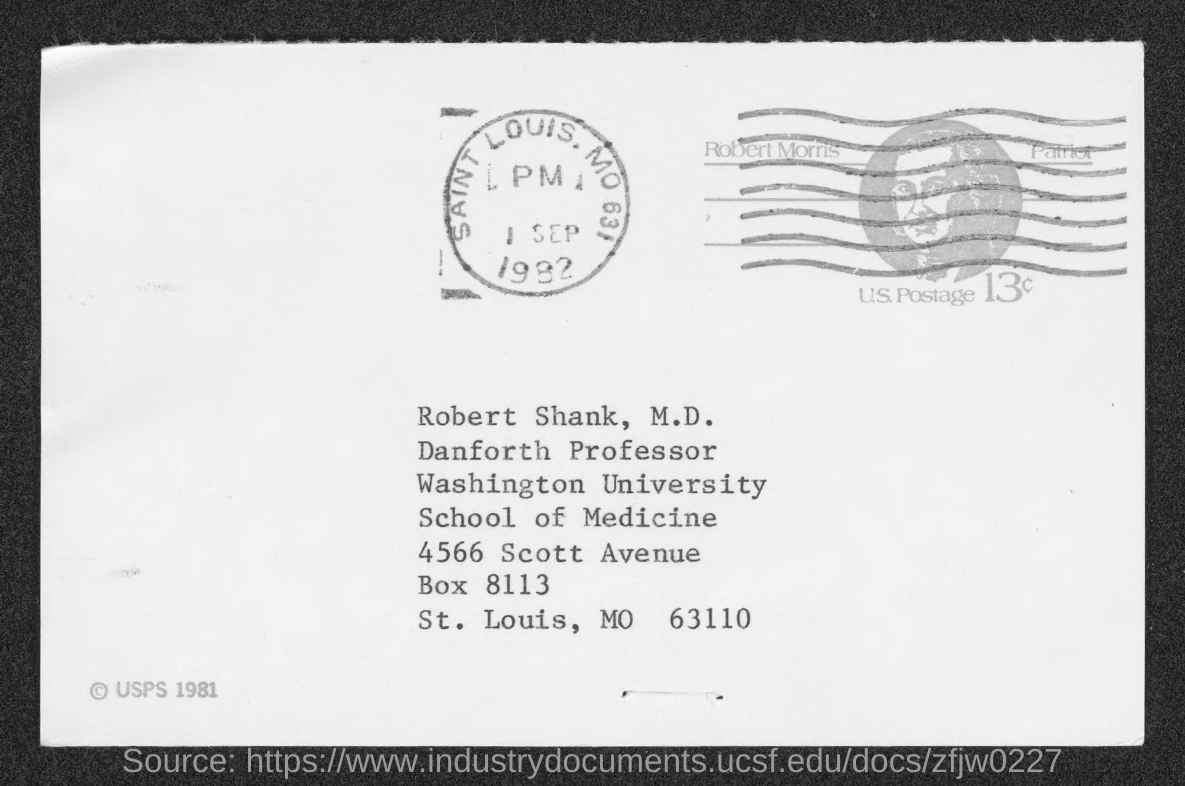What is the date mentioned in the document ?
Give a very brief answer. 1 SEP 1982. 